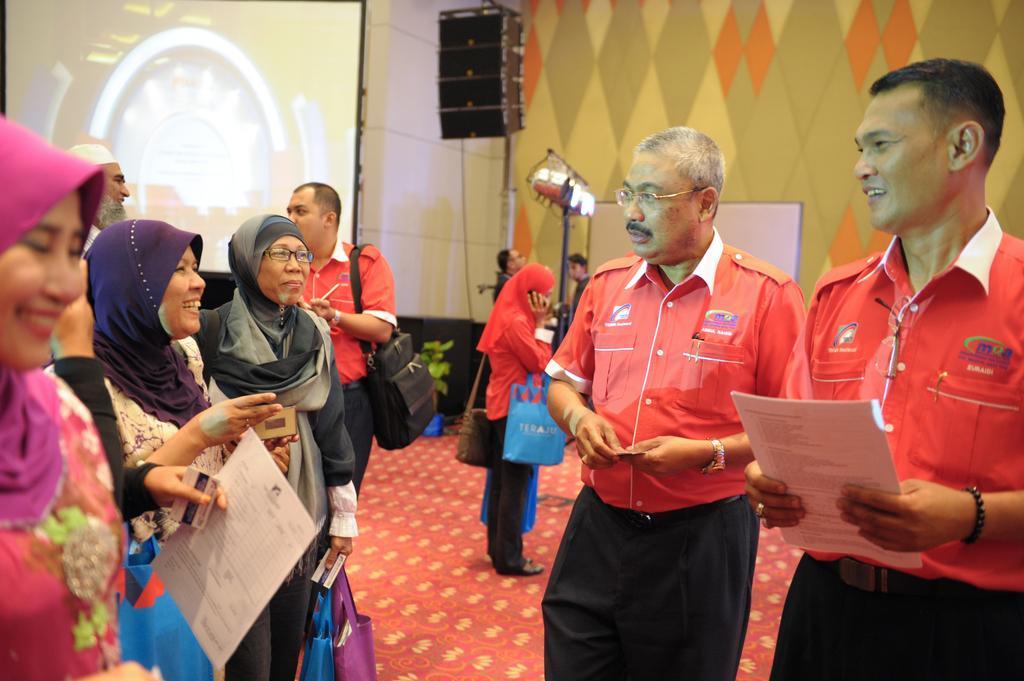In one or two sentences, can you explain what this image depicts? On the right there is a man who is wearing red shirt and trouser. He is holding the papers, beside him we can see another man who is wearing spectacle, shirt, watch and trouser. He is holding a card. On the right there is a woman who is wearing pink color scarf and dress. She is holding a credit card, beside her we can see another woman who is wearing black dress. She is holding a card and paper. Beside her we can see another woman who is wearing purple color scarf and white shirt. She is talking with him. Beside her we can see an old woman who is wearing scarf, spectacle, shirt and jeans. She is holding a card and two bags. In the back there is a man who is wearing shirt, watch and trouser. He is holding a black bag. He is talking with the man who is wearing white cap and white dress. Beside him we can see another woman who is wearing red dress, black trouser and shoe. She is holding a mobile phone and two bags. She is standing on the carpet. In the background there are two persons who are standing near to the poles, lights and board. Beside them there is a plant near the wall. In the top left corner there is a projector screen. At the top we can see the speaker. In the top right there is a wall. 